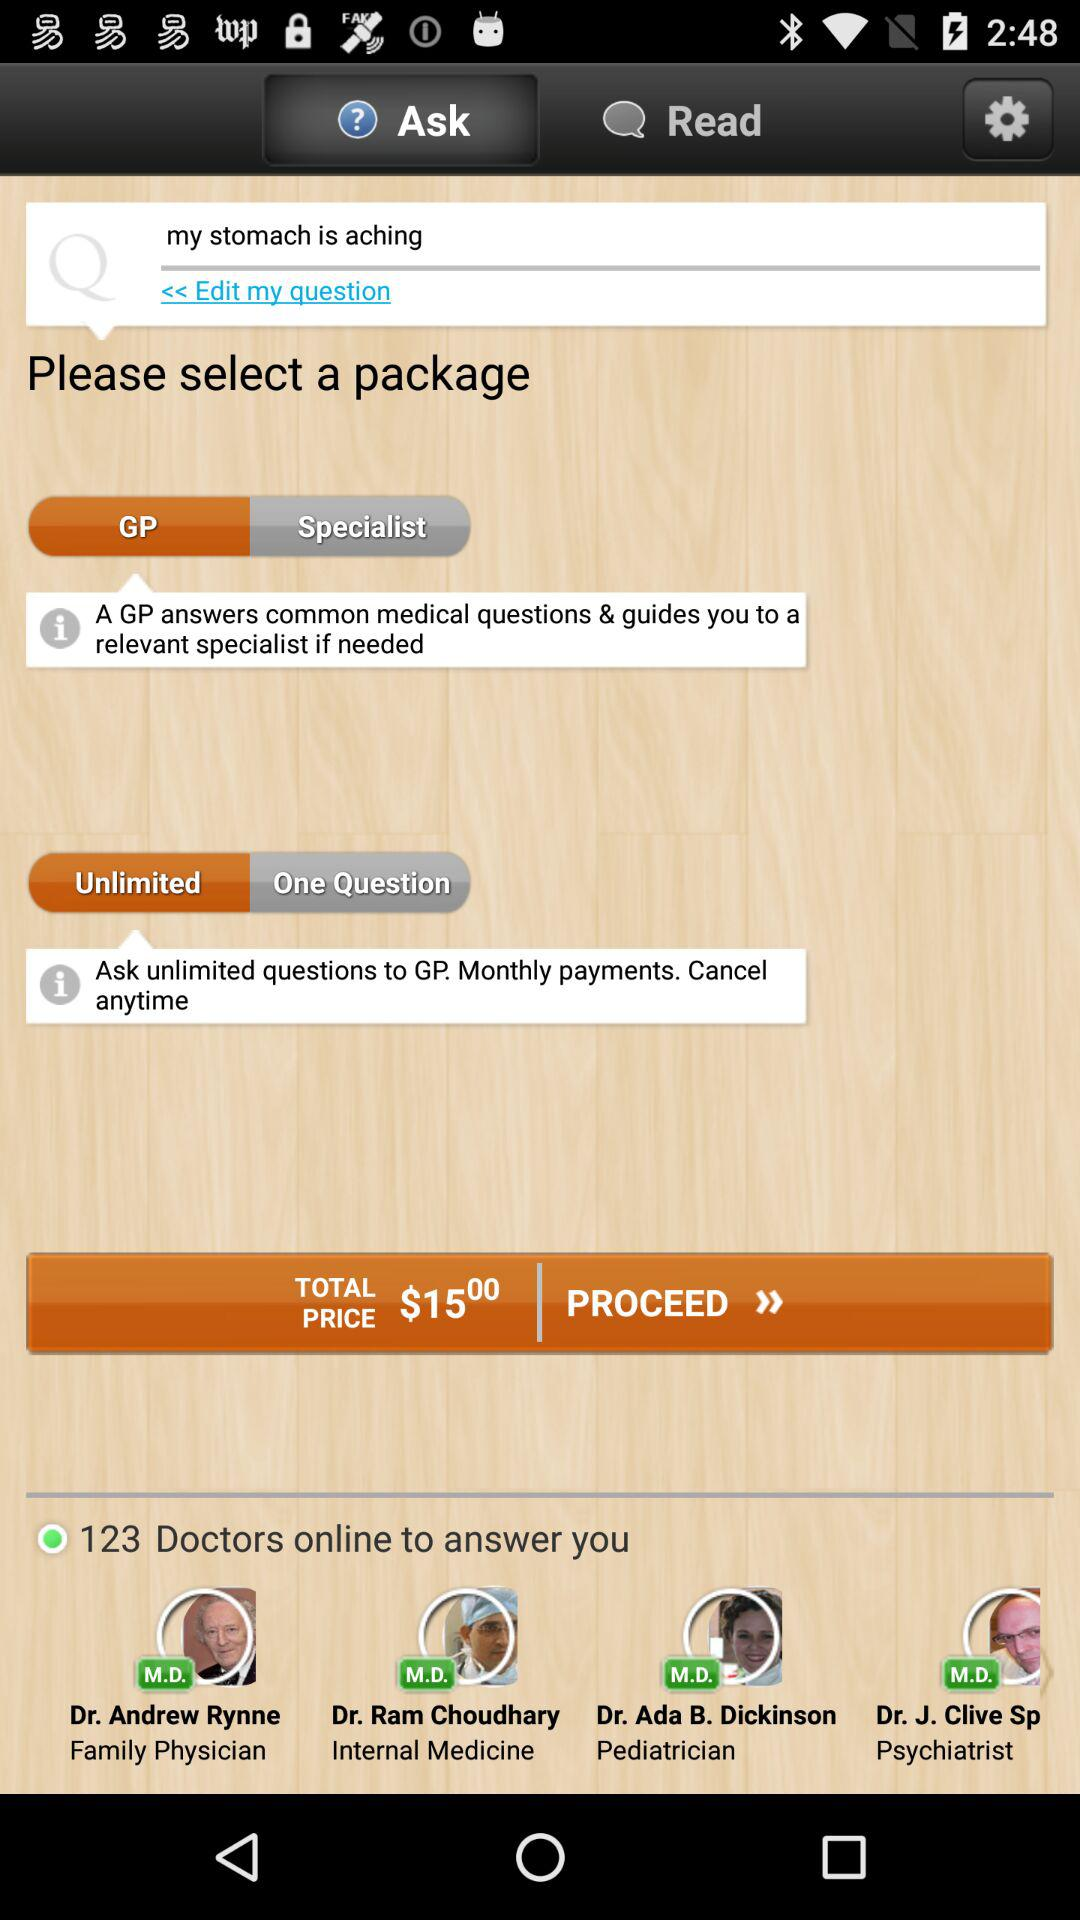How many doctors are online?
Answer the question using a single word or phrase. 123 